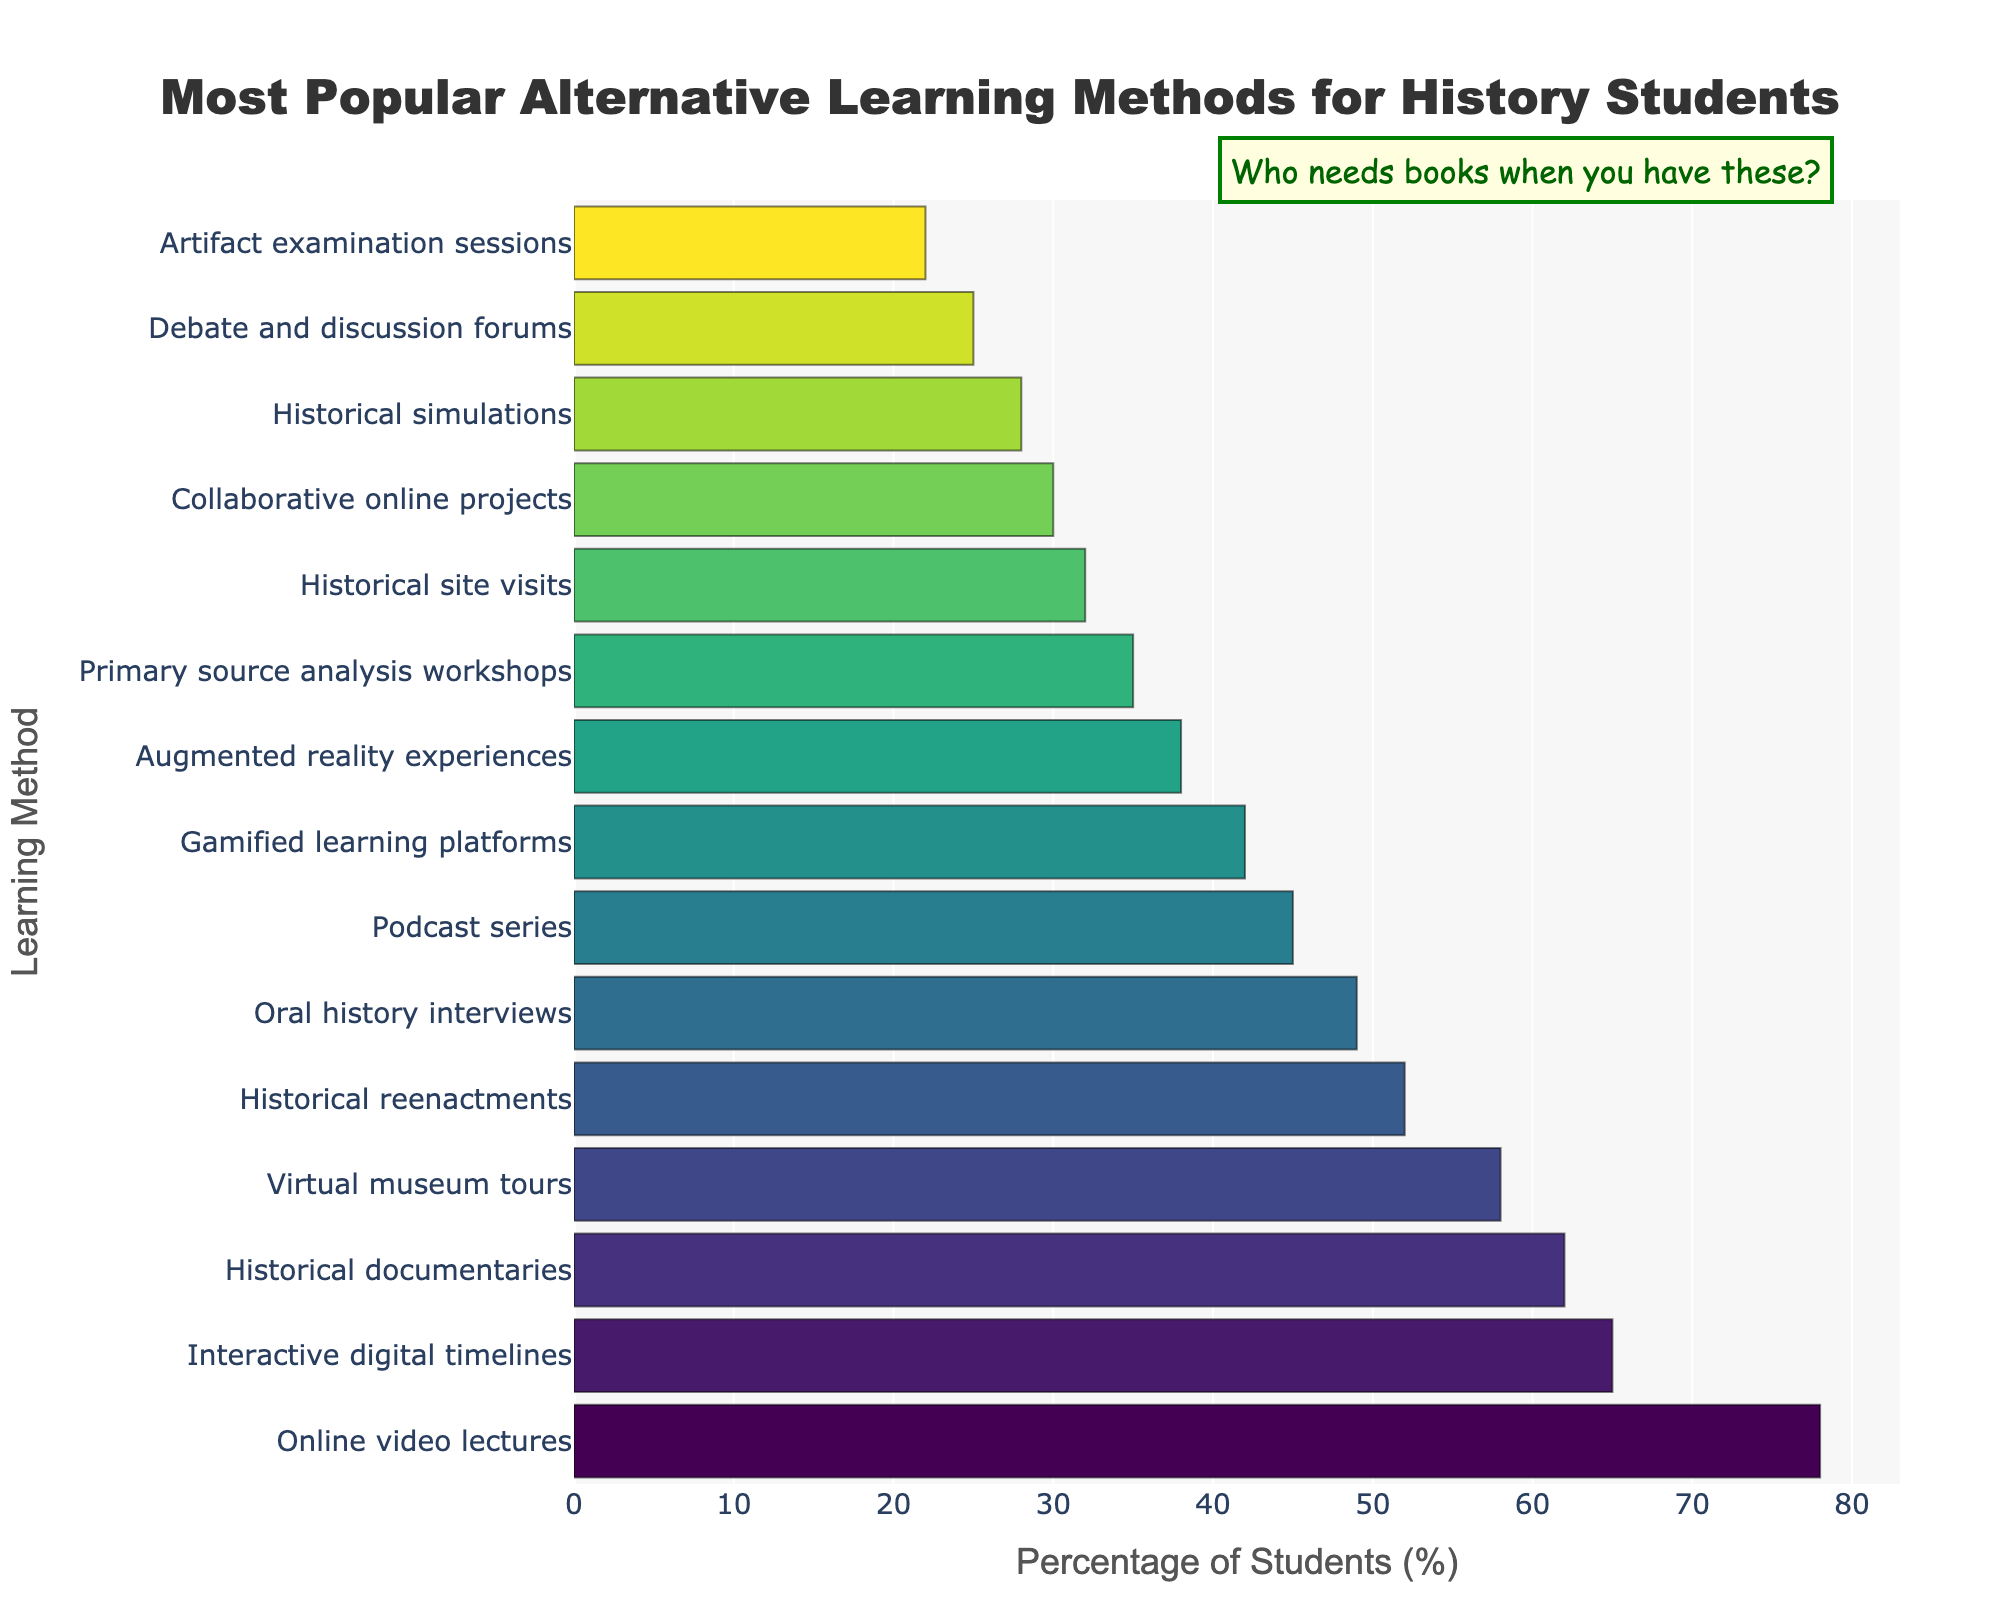Which method is the most popular among history students? The data shows the percentage usage of each method. The highest percentage corresponds to the most popular method.
Answer: Online video lectures Which method has the lowest percentage of student usage? To find the method with the lowest usage, look for the smallest percentage value in the chart.
Answer: Artifact examination sessions How many methods have at least 50% of students using them? Count the number of methods with percentages 50% or higher.
Answer: 5 How much more popular are online video lectures compared to primary source analysis workshops? Subtract the percentage of primary source analysis workshops from that of online video lectures. \( 78 - 35 = 43 \)
Answer: 43 Which method is more popular: Virtual museum tours or Gamified learning platforms? Compare their percentages. Virtual museum tours have 58%, and Gamified learning platforms have 42%.
Answer: Virtual museum tours Is historical documentaries more popular than historical reenactments? Compare the percentages of historical documentaries (62%) and historical reenactments (52%).
Answer: Yes By how many percentage points do oral history interviews differ from podcasts series? Subtract the percentage of podcasts (45%) from oral history interviews (49%). \( 49 - 45 = 4 \)
Answer: 4 Arrange the methods with a percentage below 40% in descending order. List methods with percentages below 40% and order them from highest to lowest.
Answer: Augmented reality experiences, Primary source analysis workshops, Historical site visits, Collaborative online projects, Historical simulations, Debate and discussion forums, Artifact examination sessions What’s the average percentage of the three least popular methods? Sum the percentages of the three least popular methods (28, 25, 22) and divide by 3. \((28 + 25 + 22) / 3 = 25\)
Answer: 25 